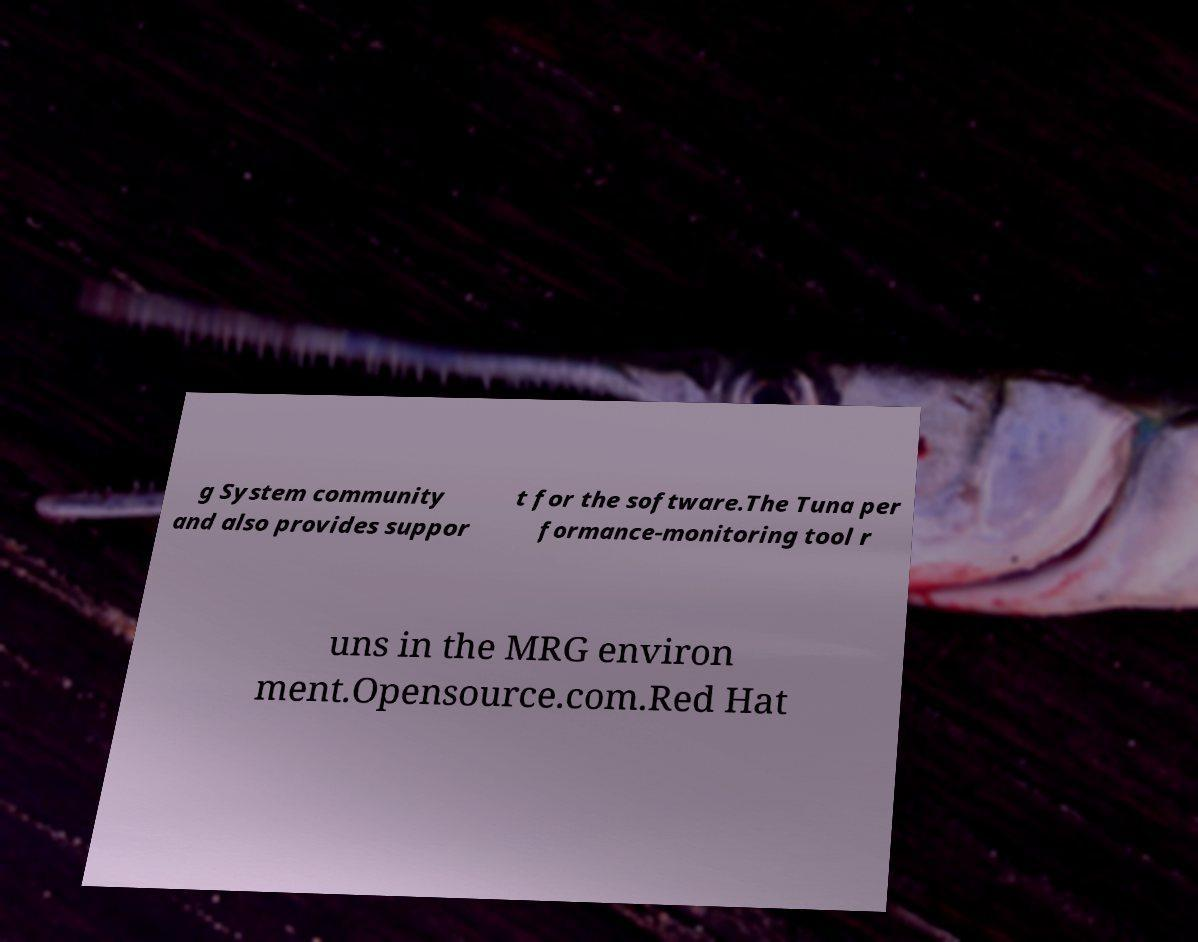Can you read and provide the text displayed in the image?This photo seems to have some interesting text. Can you extract and type it out for me? g System community and also provides suppor t for the software.The Tuna per formance-monitoring tool r uns in the MRG environ ment.Opensource.com.Red Hat 